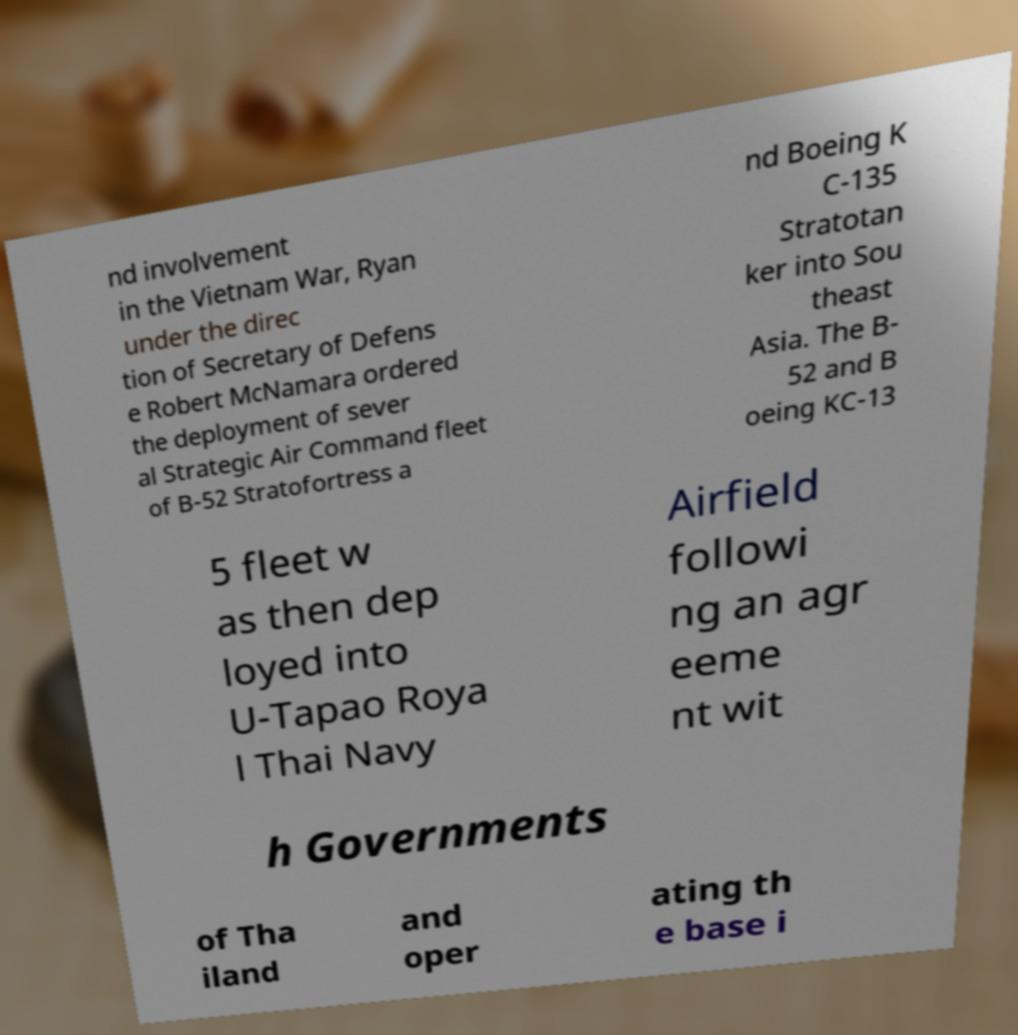Please identify and transcribe the text found in this image. nd involvement in the Vietnam War, Ryan under the direc tion of Secretary of Defens e Robert McNamara ordered the deployment of sever al Strategic Air Command fleet of B-52 Stratofortress a nd Boeing K C-135 Stratotan ker into Sou theast Asia. The B- 52 and B oeing KC-13 5 fleet w as then dep loyed into U-Tapao Roya l Thai Navy Airfield followi ng an agr eeme nt wit h Governments of Tha iland and oper ating th e base i 